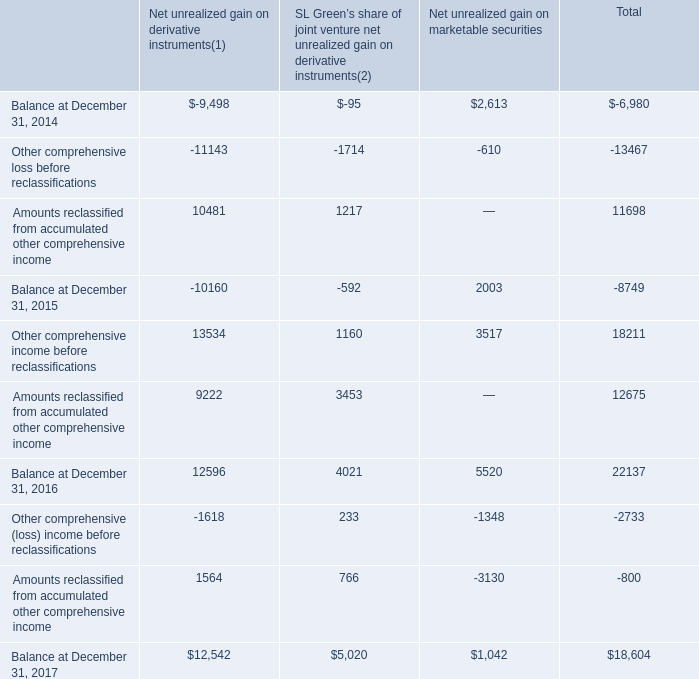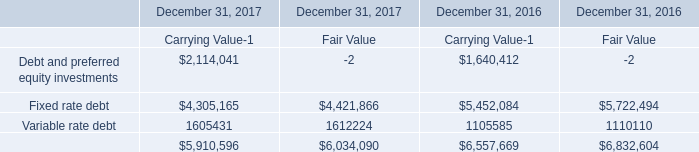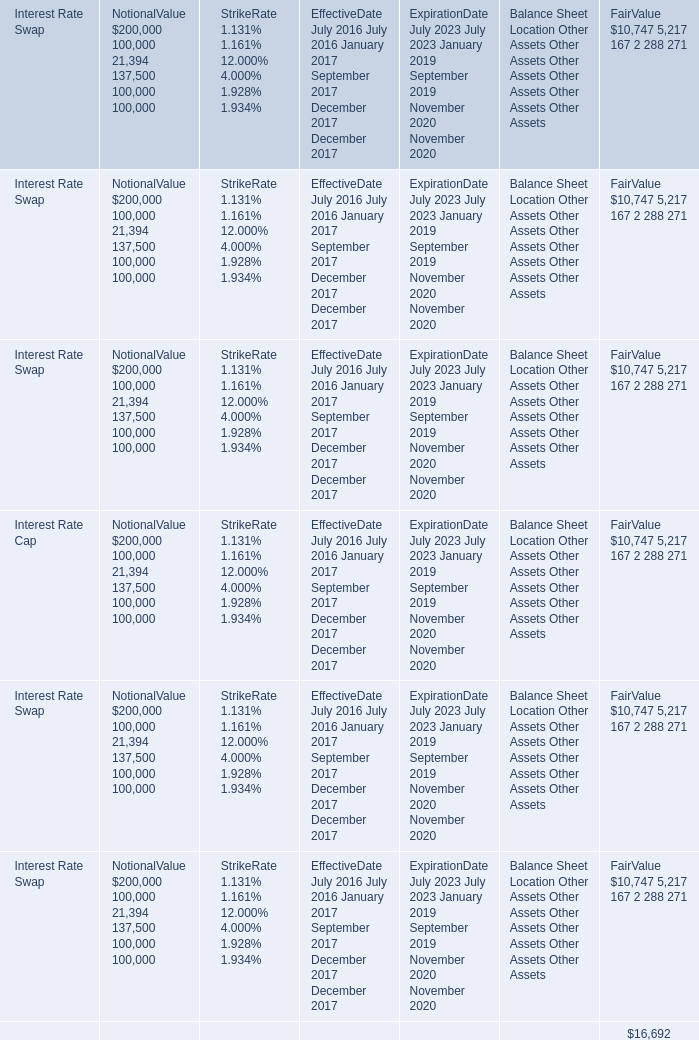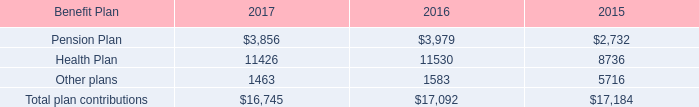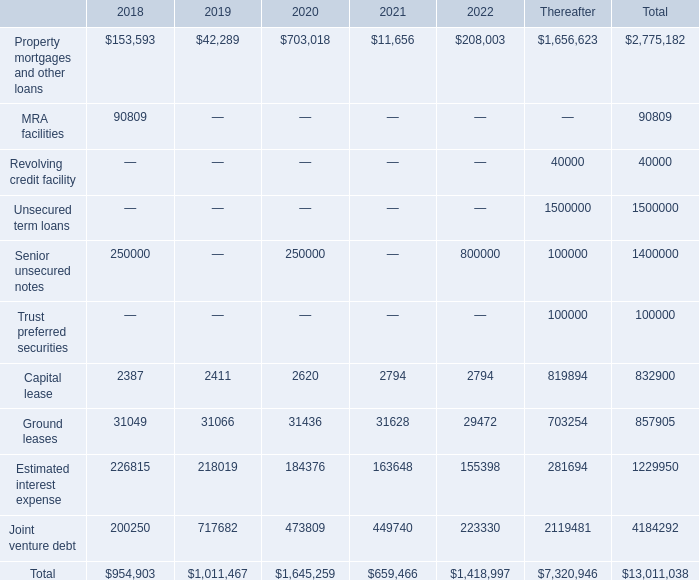what's the total amount of Joint venture debt of 2020, Variable rate debt of December 31, 2016 Fair Value, and Total of 2019 ? 
Computations: ((473809.0 + 1110110.0) + 1011467.0)
Answer: 2595386.0. 